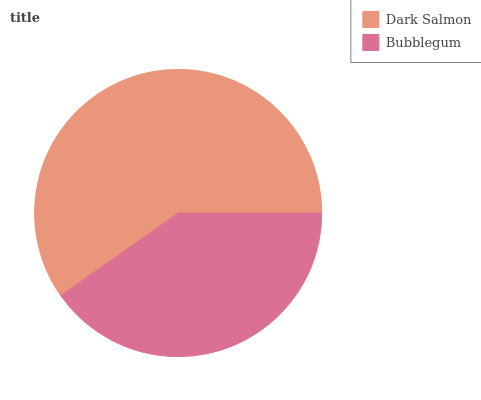Is Bubblegum the minimum?
Answer yes or no. Yes. Is Dark Salmon the maximum?
Answer yes or no. Yes. Is Bubblegum the maximum?
Answer yes or no. No. Is Dark Salmon greater than Bubblegum?
Answer yes or no. Yes. Is Bubblegum less than Dark Salmon?
Answer yes or no. Yes. Is Bubblegum greater than Dark Salmon?
Answer yes or no. No. Is Dark Salmon less than Bubblegum?
Answer yes or no. No. Is Dark Salmon the high median?
Answer yes or no. Yes. Is Bubblegum the low median?
Answer yes or no. Yes. Is Bubblegum the high median?
Answer yes or no. No. Is Dark Salmon the low median?
Answer yes or no. No. 